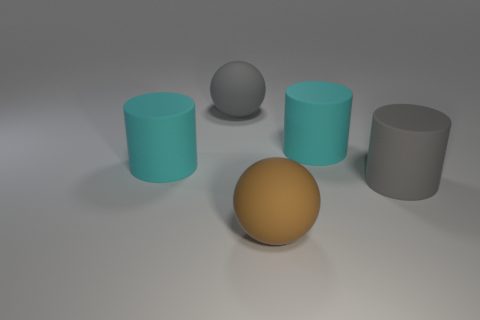Add 2 yellow metal balls. How many objects exist? 7 Subtract all cylinders. How many objects are left? 2 Subtract 0 red cubes. How many objects are left? 5 Subtract all large gray balls. Subtract all cyan rubber cylinders. How many objects are left? 2 Add 5 cylinders. How many cylinders are left? 8 Add 1 small cyan blocks. How many small cyan blocks exist? 1 